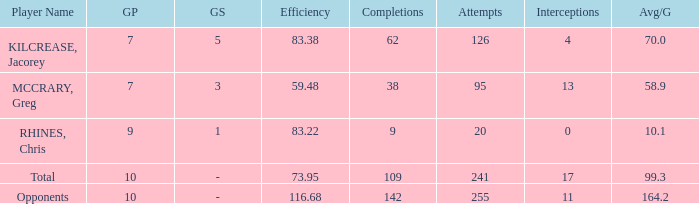Parse the full table. {'header': ['Player Name', 'GP', 'GS', 'Efficiency', 'Completions', 'Attempts', 'Interceptions', 'Avg/G'], 'rows': [['KILCREASE, Jacorey', '7', '5', '83.38', '62', '126', '4', '70.0'], ['MCCRARY, Greg', '7', '3', '59.48', '38', '95', '13', '58.9'], ['RHINES, Chris', '9', '1', '83.22', '9', '20', '0', '10.1'], ['Total', '10', '-', '73.95', '109', '241', '17', '99.3'], ['Opponents', '10', '-', '116.68', '142', '255', '11', '164.2']]} What is the total avg/g of McCrary, Greg? 1.0. 